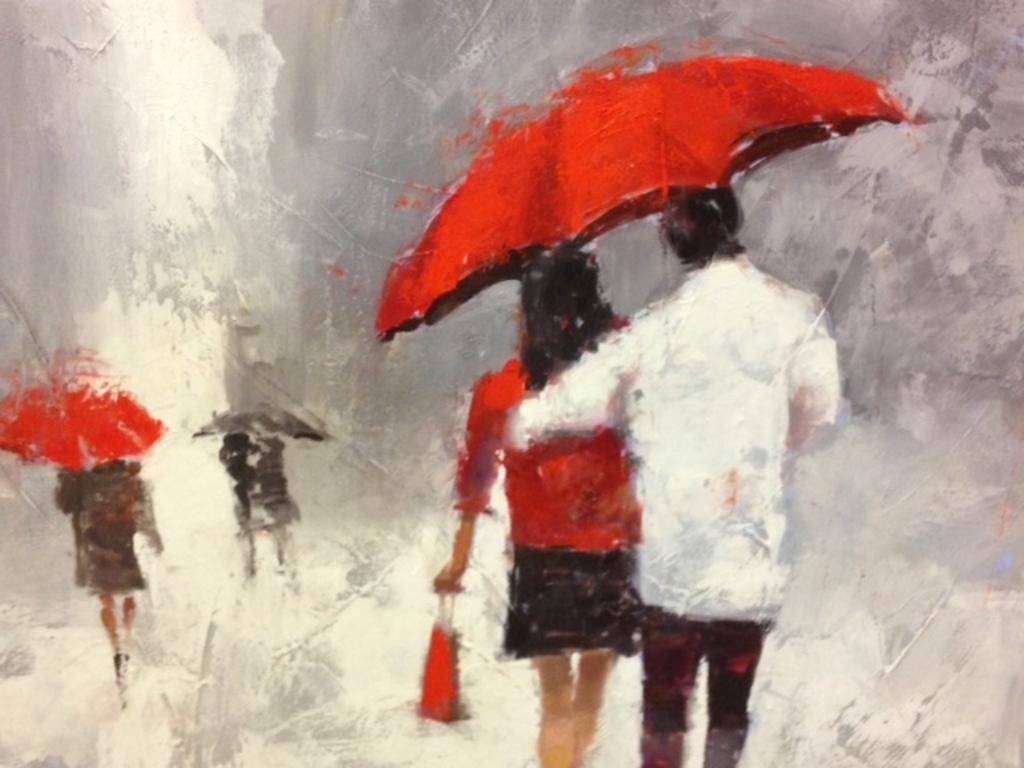Describe this image in one or two sentences. This is an edited image , in the image there are few persons holding the umbrella and walking on the road. 